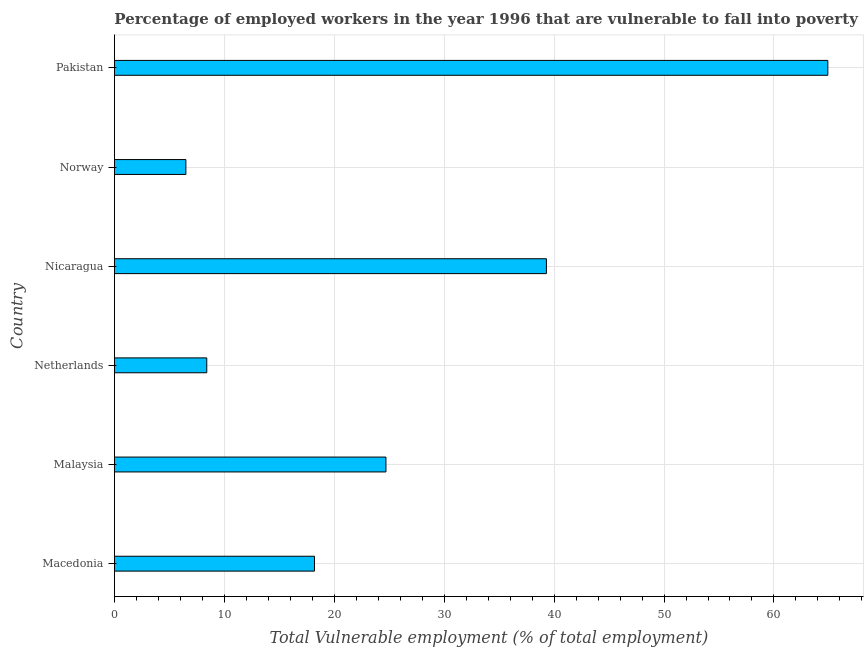Does the graph contain any zero values?
Your answer should be compact. No. What is the title of the graph?
Give a very brief answer. Percentage of employed workers in the year 1996 that are vulnerable to fall into poverty. What is the label or title of the X-axis?
Make the answer very short. Total Vulnerable employment (% of total employment). What is the label or title of the Y-axis?
Give a very brief answer. Country. What is the total vulnerable employment in Norway?
Offer a terse response. 6.5. Across all countries, what is the maximum total vulnerable employment?
Your answer should be compact. 64.9. Across all countries, what is the minimum total vulnerable employment?
Your answer should be very brief. 6.5. In which country was the total vulnerable employment minimum?
Your answer should be very brief. Norway. What is the sum of the total vulnerable employment?
Provide a succinct answer. 162. What is the average total vulnerable employment per country?
Your answer should be very brief. 27. What is the median total vulnerable employment?
Your answer should be very brief. 21.45. What is the difference between the highest and the second highest total vulnerable employment?
Ensure brevity in your answer.  25.6. Is the sum of the total vulnerable employment in Norway and Pakistan greater than the maximum total vulnerable employment across all countries?
Your answer should be very brief. Yes. What is the difference between the highest and the lowest total vulnerable employment?
Ensure brevity in your answer.  58.4. In how many countries, is the total vulnerable employment greater than the average total vulnerable employment taken over all countries?
Give a very brief answer. 2. How many bars are there?
Your response must be concise. 6. What is the difference between two consecutive major ticks on the X-axis?
Provide a short and direct response. 10. Are the values on the major ticks of X-axis written in scientific E-notation?
Your answer should be compact. No. What is the Total Vulnerable employment (% of total employment) of Macedonia?
Provide a short and direct response. 18.2. What is the Total Vulnerable employment (% of total employment) in Malaysia?
Offer a terse response. 24.7. What is the Total Vulnerable employment (% of total employment) of Netherlands?
Provide a short and direct response. 8.4. What is the Total Vulnerable employment (% of total employment) of Nicaragua?
Your answer should be compact. 39.3. What is the Total Vulnerable employment (% of total employment) of Norway?
Provide a short and direct response. 6.5. What is the Total Vulnerable employment (% of total employment) in Pakistan?
Offer a terse response. 64.9. What is the difference between the Total Vulnerable employment (% of total employment) in Macedonia and Netherlands?
Give a very brief answer. 9.8. What is the difference between the Total Vulnerable employment (% of total employment) in Macedonia and Nicaragua?
Keep it short and to the point. -21.1. What is the difference between the Total Vulnerable employment (% of total employment) in Macedonia and Norway?
Offer a very short reply. 11.7. What is the difference between the Total Vulnerable employment (% of total employment) in Macedonia and Pakistan?
Keep it short and to the point. -46.7. What is the difference between the Total Vulnerable employment (% of total employment) in Malaysia and Netherlands?
Your answer should be compact. 16.3. What is the difference between the Total Vulnerable employment (% of total employment) in Malaysia and Nicaragua?
Keep it short and to the point. -14.6. What is the difference between the Total Vulnerable employment (% of total employment) in Malaysia and Pakistan?
Make the answer very short. -40.2. What is the difference between the Total Vulnerable employment (% of total employment) in Netherlands and Nicaragua?
Provide a short and direct response. -30.9. What is the difference between the Total Vulnerable employment (% of total employment) in Netherlands and Pakistan?
Offer a terse response. -56.5. What is the difference between the Total Vulnerable employment (% of total employment) in Nicaragua and Norway?
Your response must be concise. 32.8. What is the difference between the Total Vulnerable employment (% of total employment) in Nicaragua and Pakistan?
Make the answer very short. -25.6. What is the difference between the Total Vulnerable employment (% of total employment) in Norway and Pakistan?
Provide a succinct answer. -58.4. What is the ratio of the Total Vulnerable employment (% of total employment) in Macedonia to that in Malaysia?
Provide a short and direct response. 0.74. What is the ratio of the Total Vulnerable employment (% of total employment) in Macedonia to that in Netherlands?
Provide a succinct answer. 2.17. What is the ratio of the Total Vulnerable employment (% of total employment) in Macedonia to that in Nicaragua?
Offer a terse response. 0.46. What is the ratio of the Total Vulnerable employment (% of total employment) in Macedonia to that in Pakistan?
Your answer should be very brief. 0.28. What is the ratio of the Total Vulnerable employment (% of total employment) in Malaysia to that in Netherlands?
Offer a terse response. 2.94. What is the ratio of the Total Vulnerable employment (% of total employment) in Malaysia to that in Nicaragua?
Your answer should be very brief. 0.63. What is the ratio of the Total Vulnerable employment (% of total employment) in Malaysia to that in Pakistan?
Provide a short and direct response. 0.38. What is the ratio of the Total Vulnerable employment (% of total employment) in Netherlands to that in Nicaragua?
Your answer should be compact. 0.21. What is the ratio of the Total Vulnerable employment (% of total employment) in Netherlands to that in Norway?
Your answer should be very brief. 1.29. What is the ratio of the Total Vulnerable employment (% of total employment) in Netherlands to that in Pakistan?
Your answer should be very brief. 0.13. What is the ratio of the Total Vulnerable employment (% of total employment) in Nicaragua to that in Norway?
Provide a short and direct response. 6.05. What is the ratio of the Total Vulnerable employment (% of total employment) in Nicaragua to that in Pakistan?
Provide a short and direct response. 0.61. 